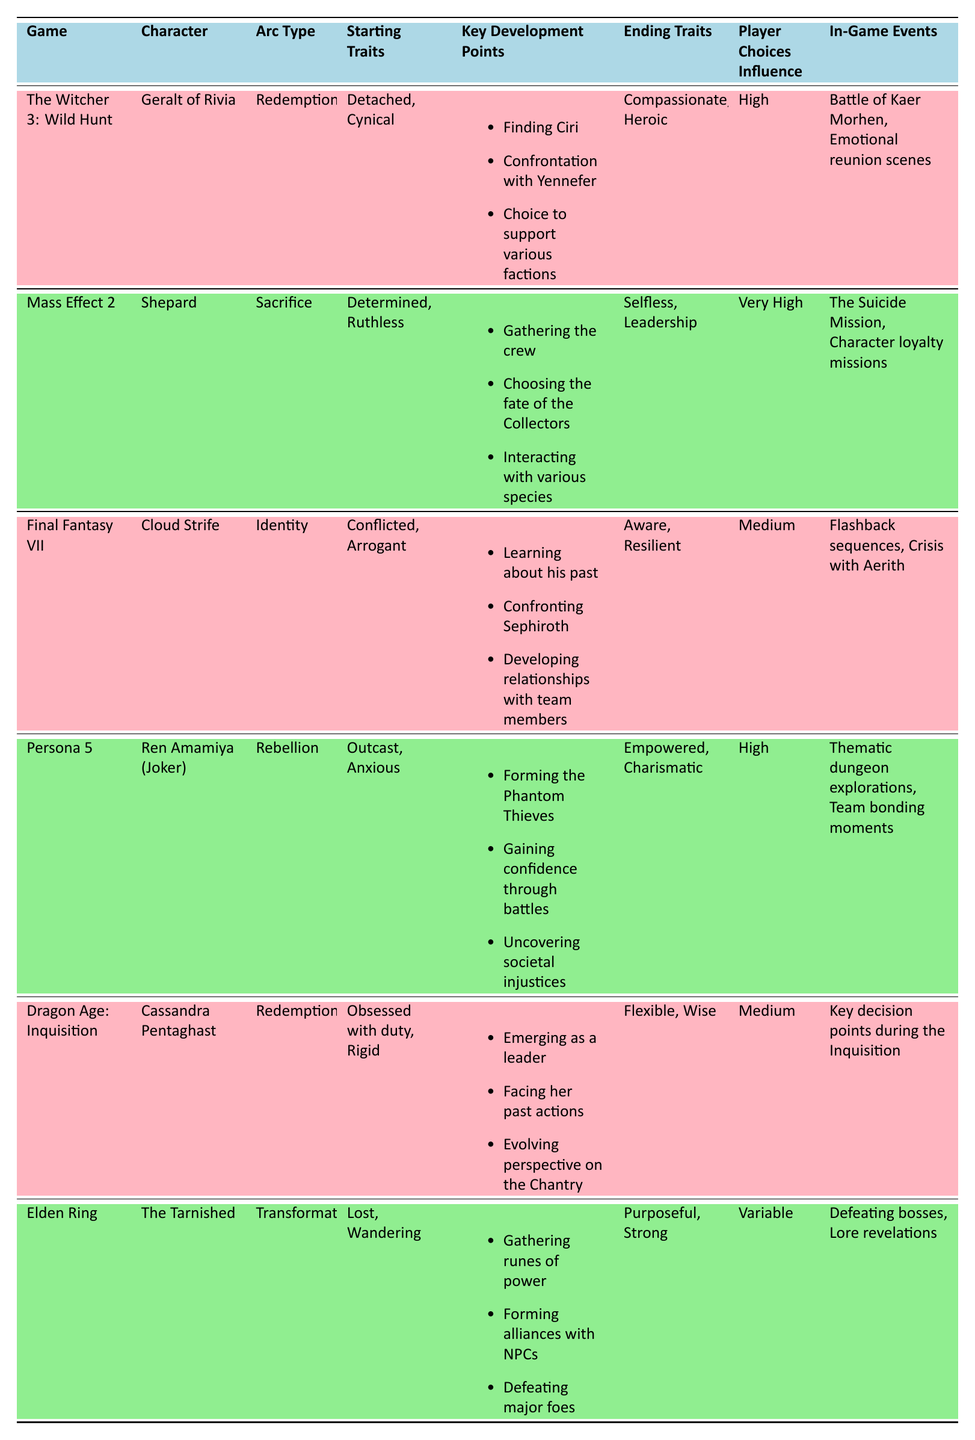What is the arc type of Geralt of Rivia? According to the table, Geralt of Rivia has an arc type labeled as "Redemption."
Answer: Redemption Which character has a transformation arc? The table indicates that the character with a transformation arc is "The Tarnished" from Elden Ring.
Answer: The Tarnished What were the starting traits of Cloud Strife? The starting traits for Cloud Strife are noted in the table as "Conflicted, Arrogant."
Answer: Conflicted, Arrogant How many characters have a high player choice influence? The table lists 4 characters with "High" as their player choices influence: Geralt of Rivia, Ren Amamiya, and Cassandra Pentaghast.
Answer: 4 Which game features the key development point "Gathering the crew"? The game featuring the key development point "Gathering the crew" is "Mass Effect 2" according to the table.
Answer: Mass Effect 2 Is the ending trait of Ren Amamiya (Joker) described as "Empowered"? The table confirms that the ending traits for Ren Amamiya (Joker) are "Empowered, Charismatic."
Answer: Yes What is the difference in player choice influence between Shepard and Cassandra Pentaghast? Shepard's player choice influence is "Very High," while Cassandra Pentaghast's is "Medium." Assigning values: Very High = 3, Medium = 1, the difference is 3 - 1 = 2.
Answer: 2 Which character evolves from "Obsessed with duty" to "Flexible"? According to the table, Cassandra Pentaghast evolves from "Obsessed with duty" to "Flexible."
Answer: Cassandra Pentaghast What is the average player choice influence from the listed characters? The influences can be assigned values: High = 2, Very High = 3, Medium = 1, and Variable is treated as indeterminate. We have: 3 (Shepard) + 2 (Geralt) + 1 (Cloud) + 2 (Ren Amamiya) + 1 (Cassandra) = 9. There are 5 characters. The average is 9/5 = 1.8.
Answer: 1.8 Do any characters have the ending trait of "Aware"? The table shows that Cloud Strife has the ending trait "Aware."
Answer: Yes What major events are associated with the ending transformation of The Tarnished? The in-game events associated with The Tarnished's transformation include "Defeating bosses" and "Lore revelations."
Answer: Defeating bosses, Lore revelations 